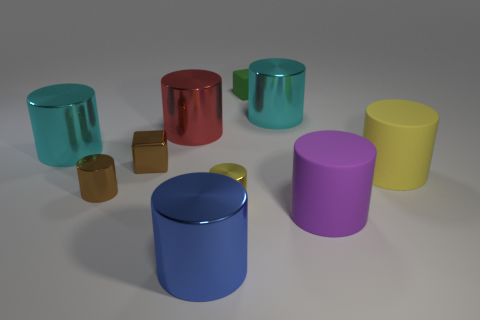What number of things are big yellow things or cylinders that are in front of the large purple thing?
Offer a very short reply. 2. There is a small metallic thing that is the same color as the tiny metallic cube; what is its shape?
Provide a succinct answer. Cylinder. How many purple objects have the same size as the red metal cylinder?
Provide a succinct answer. 1. What number of yellow objects are either large metal cylinders or metallic objects?
Your response must be concise. 1. What shape is the thing that is behind the big metallic thing behind the big red shiny thing?
Your answer should be compact. Cube. What shape is the matte object that is the same size as the yellow shiny thing?
Provide a short and direct response. Cube. Are there any metal cylinders of the same color as the metal cube?
Make the answer very short. Yes. Are there the same number of brown cylinders that are to the right of the red metallic cylinder and small green rubber blocks that are behind the small green object?
Your response must be concise. Yes. Is the shape of the purple rubber thing the same as the small object behind the brown cube?
Make the answer very short. No. How many other objects are there of the same material as the blue cylinder?
Offer a very short reply. 6. 